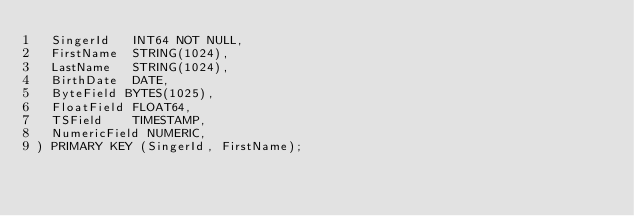Convert code to text. <code><loc_0><loc_0><loc_500><loc_500><_SQL_>  SingerId   INT64 NOT NULL,
  FirstName  STRING(1024),
  LastName   STRING(1024),
  BirthDate  DATE,
  ByteField BYTES(1025),
  FloatField FLOAT64,
  TSField    TIMESTAMP,
  NumericField NUMERIC,
) PRIMARY KEY (SingerId, FirstName);
</code> 